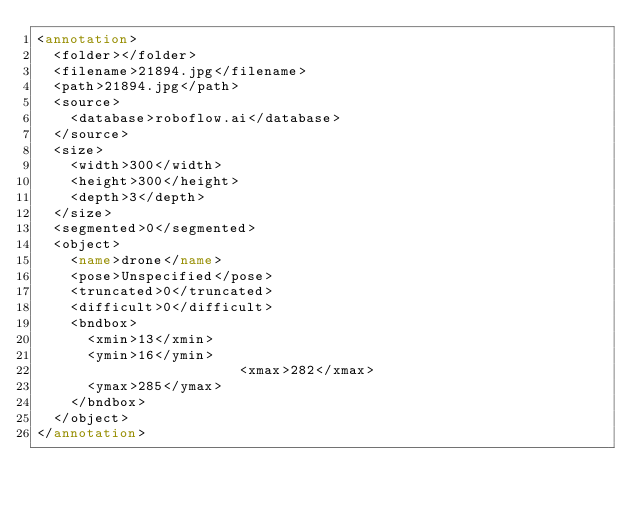Convert code to text. <code><loc_0><loc_0><loc_500><loc_500><_XML_><annotation>
	<folder></folder>
	<filename>21894.jpg</filename>
	<path>21894.jpg</path>
	<source>
		<database>roboflow.ai</database>
	</source>
	<size>
		<width>300</width>
		<height>300</height>
		<depth>3</depth>
	</size>
	<segmented>0</segmented>
	<object>
		<name>drone</name>
		<pose>Unspecified</pose>
		<truncated>0</truncated>
		<difficult>0</difficult>
		<bndbox>
			<xmin>13</xmin>
			<ymin>16</ymin>
                        <xmax>282</xmax>
			<ymax>285</ymax>
		</bndbox>
	</object>
</annotation>
</code> 